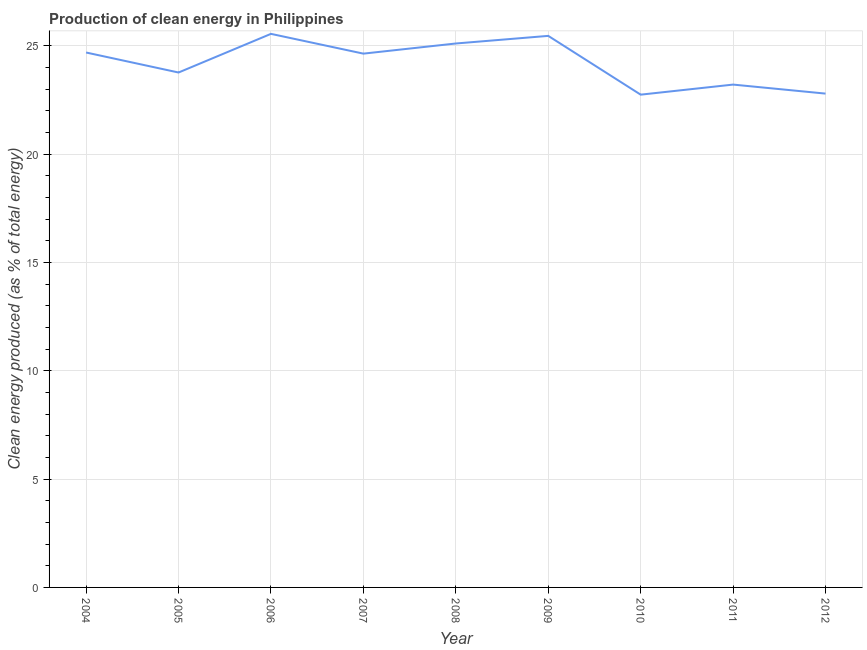What is the production of clean energy in 2009?
Offer a terse response. 25.46. Across all years, what is the maximum production of clean energy?
Provide a short and direct response. 25.55. Across all years, what is the minimum production of clean energy?
Your answer should be compact. 22.75. What is the sum of the production of clean energy?
Offer a very short reply. 217.98. What is the difference between the production of clean energy in 2004 and 2012?
Make the answer very short. 1.9. What is the average production of clean energy per year?
Provide a short and direct response. 24.22. What is the median production of clean energy?
Make the answer very short. 24.64. In how many years, is the production of clean energy greater than 15 %?
Give a very brief answer. 9. Do a majority of the years between 2011 and 2012 (inclusive) have production of clean energy greater than 8 %?
Provide a succinct answer. Yes. What is the ratio of the production of clean energy in 2006 to that in 2012?
Give a very brief answer. 1.12. Is the difference between the production of clean energy in 2004 and 2006 greater than the difference between any two years?
Ensure brevity in your answer.  No. What is the difference between the highest and the second highest production of clean energy?
Offer a terse response. 0.09. What is the difference between the highest and the lowest production of clean energy?
Offer a very short reply. 2.81. In how many years, is the production of clean energy greater than the average production of clean energy taken over all years?
Provide a short and direct response. 5. Does the production of clean energy monotonically increase over the years?
Your response must be concise. No. How many years are there in the graph?
Your answer should be compact. 9. What is the difference between two consecutive major ticks on the Y-axis?
Offer a very short reply. 5. Are the values on the major ticks of Y-axis written in scientific E-notation?
Provide a short and direct response. No. Does the graph contain any zero values?
Provide a short and direct response. No. Does the graph contain grids?
Provide a succinct answer. Yes. What is the title of the graph?
Provide a succinct answer. Production of clean energy in Philippines. What is the label or title of the Y-axis?
Your answer should be very brief. Clean energy produced (as % of total energy). What is the Clean energy produced (as % of total energy) of 2004?
Provide a short and direct response. 24.69. What is the Clean energy produced (as % of total energy) of 2005?
Offer a terse response. 23.77. What is the Clean energy produced (as % of total energy) in 2006?
Offer a very short reply. 25.55. What is the Clean energy produced (as % of total energy) of 2007?
Offer a terse response. 24.64. What is the Clean energy produced (as % of total energy) of 2008?
Provide a short and direct response. 25.11. What is the Clean energy produced (as % of total energy) in 2009?
Provide a succinct answer. 25.46. What is the Clean energy produced (as % of total energy) in 2010?
Your response must be concise. 22.75. What is the Clean energy produced (as % of total energy) of 2011?
Provide a short and direct response. 23.21. What is the Clean energy produced (as % of total energy) of 2012?
Keep it short and to the point. 22.8. What is the difference between the Clean energy produced (as % of total energy) in 2004 and 2005?
Provide a short and direct response. 0.92. What is the difference between the Clean energy produced (as % of total energy) in 2004 and 2006?
Offer a very short reply. -0.86. What is the difference between the Clean energy produced (as % of total energy) in 2004 and 2007?
Give a very brief answer. 0.05. What is the difference between the Clean energy produced (as % of total energy) in 2004 and 2008?
Offer a very short reply. -0.42. What is the difference between the Clean energy produced (as % of total energy) in 2004 and 2009?
Your answer should be compact. -0.77. What is the difference between the Clean energy produced (as % of total energy) in 2004 and 2010?
Your response must be concise. 1.95. What is the difference between the Clean energy produced (as % of total energy) in 2004 and 2011?
Your answer should be very brief. 1.48. What is the difference between the Clean energy produced (as % of total energy) in 2004 and 2012?
Keep it short and to the point. 1.9. What is the difference between the Clean energy produced (as % of total energy) in 2005 and 2006?
Offer a very short reply. -1.78. What is the difference between the Clean energy produced (as % of total energy) in 2005 and 2007?
Make the answer very short. -0.87. What is the difference between the Clean energy produced (as % of total energy) in 2005 and 2008?
Give a very brief answer. -1.34. What is the difference between the Clean energy produced (as % of total energy) in 2005 and 2009?
Ensure brevity in your answer.  -1.69. What is the difference between the Clean energy produced (as % of total energy) in 2005 and 2010?
Offer a terse response. 1.02. What is the difference between the Clean energy produced (as % of total energy) in 2005 and 2011?
Ensure brevity in your answer.  0.56. What is the difference between the Clean energy produced (as % of total energy) in 2005 and 2012?
Provide a short and direct response. 0.97. What is the difference between the Clean energy produced (as % of total energy) in 2006 and 2007?
Make the answer very short. 0.91. What is the difference between the Clean energy produced (as % of total energy) in 2006 and 2008?
Give a very brief answer. 0.44. What is the difference between the Clean energy produced (as % of total energy) in 2006 and 2009?
Your answer should be compact. 0.09. What is the difference between the Clean energy produced (as % of total energy) in 2006 and 2010?
Ensure brevity in your answer.  2.81. What is the difference between the Clean energy produced (as % of total energy) in 2006 and 2011?
Your answer should be compact. 2.34. What is the difference between the Clean energy produced (as % of total energy) in 2006 and 2012?
Provide a short and direct response. 2.76. What is the difference between the Clean energy produced (as % of total energy) in 2007 and 2008?
Ensure brevity in your answer.  -0.47. What is the difference between the Clean energy produced (as % of total energy) in 2007 and 2009?
Your answer should be compact. -0.82. What is the difference between the Clean energy produced (as % of total energy) in 2007 and 2010?
Provide a short and direct response. 1.89. What is the difference between the Clean energy produced (as % of total energy) in 2007 and 2011?
Provide a succinct answer. 1.43. What is the difference between the Clean energy produced (as % of total energy) in 2007 and 2012?
Provide a succinct answer. 1.85. What is the difference between the Clean energy produced (as % of total energy) in 2008 and 2009?
Offer a terse response. -0.35. What is the difference between the Clean energy produced (as % of total energy) in 2008 and 2010?
Give a very brief answer. 2.36. What is the difference between the Clean energy produced (as % of total energy) in 2008 and 2011?
Keep it short and to the point. 1.9. What is the difference between the Clean energy produced (as % of total energy) in 2008 and 2012?
Make the answer very short. 2.31. What is the difference between the Clean energy produced (as % of total energy) in 2009 and 2010?
Keep it short and to the point. 2.71. What is the difference between the Clean energy produced (as % of total energy) in 2009 and 2011?
Provide a succinct answer. 2.25. What is the difference between the Clean energy produced (as % of total energy) in 2009 and 2012?
Your answer should be compact. 2.67. What is the difference between the Clean energy produced (as % of total energy) in 2010 and 2011?
Your response must be concise. -0.47. What is the difference between the Clean energy produced (as % of total energy) in 2010 and 2012?
Offer a terse response. -0.05. What is the difference between the Clean energy produced (as % of total energy) in 2011 and 2012?
Provide a short and direct response. 0.42. What is the ratio of the Clean energy produced (as % of total energy) in 2004 to that in 2005?
Your answer should be very brief. 1.04. What is the ratio of the Clean energy produced (as % of total energy) in 2004 to that in 2006?
Give a very brief answer. 0.97. What is the ratio of the Clean energy produced (as % of total energy) in 2004 to that in 2007?
Offer a terse response. 1. What is the ratio of the Clean energy produced (as % of total energy) in 2004 to that in 2009?
Keep it short and to the point. 0.97. What is the ratio of the Clean energy produced (as % of total energy) in 2004 to that in 2010?
Your response must be concise. 1.09. What is the ratio of the Clean energy produced (as % of total energy) in 2004 to that in 2011?
Ensure brevity in your answer.  1.06. What is the ratio of the Clean energy produced (as % of total energy) in 2004 to that in 2012?
Make the answer very short. 1.08. What is the ratio of the Clean energy produced (as % of total energy) in 2005 to that in 2007?
Ensure brevity in your answer.  0.96. What is the ratio of the Clean energy produced (as % of total energy) in 2005 to that in 2008?
Offer a very short reply. 0.95. What is the ratio of the Clean energy produced (as % of total energy) in 2005 to that in 2009?
Keep it short and to the point. 0.93. What is the ratio of the Clean energy produced (as % of total energy) in 2005 to that in 2010?
Ensure brevity in your answer.  1.04. What is the ratio of the Clean energy produced (as % of total energy) in 2005 to that in 2011?
Offer a very short reply. 1.02. What is the ratio of the Clean energy produced (as % of total energy) in 2005 to that in 2012?
Your answer should be compact. 1.04. What is the ratio of the Clean energy produced (as % of total energy) in 2006 to that in 2010?
Your answer should be compact. 1.12. What is the ratio of the Clean energy produced (as % of total energy) in 2006 to that in 2011?
Make the answer very short. 1.1. What is the ratio of the Clean energy produced (as % of total energy) in 2006 to that in 2012?
Offer a very short reply. 1.12. What is the ratio of the Clean energy produced (as % of total energy) in 2007 to that in 2008?
Give a very brief answer. 0.98. What is the ratio of the Clean energy produced (as % of total energy) in 2007 to that in 2010?
Make the answer very short. 1.08. What is the ratio of the Clean energy produced (as % of total energy) in 2007 to that in 2011?
Give a very brief answer. 1.06. What is the ratio of the Clean energy produced (as % of total energy) in 2007 to that in 2012?
Your answer should be compact. 1.08. What is the ratio of the Clean energy produced (as % of total energy) in 2008 to that in 2009?
Your answer should be very brief. 0.99. What is the ratio of the Clean energy produced (as % of total energy) in 2008 to that in 2010?
Your answer should be very brief. 1.1. What is the ratio of the Clean energy produced (as % of total energy) in 2008 to that in 2011?
Provide a succinct answer. 1.08. What is the ratio of the Clean energy produced (as % of total energy) in 2008 to that in 2012?
Give a very brief answer. 1.1. What is the ratio of the Clean energy produced (as % of total energy) in 2009 to that in 2010?
Your answer should be very brief. 1.12. What is the ratio of the Clean energy produced (as % of total energy) in 2009 to that in 2011?
Give a very brief answer. 1.1. What is the ratio of the Clean energy produced (as % of total energy) in 2009 to that in 2012?
Offer a terse response. 1.12. What is the ratio of the Clean energy produced (as % of total energy) in 2010 to that in 2011?
Offer a very short reply. 0.98. 